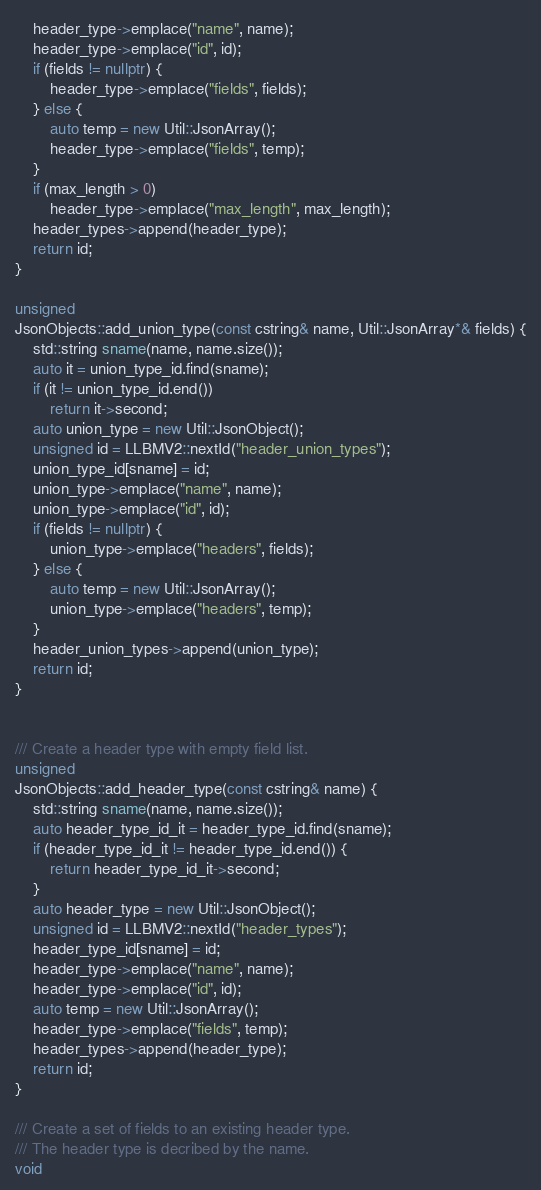Convert code to text. <code><loc_0><loc_0><loc_500><loc_500><_C++_>    header_type->emplace("name", name);
    header_type->emplace("id", id);
    if (fields != nullptr) {
        header_type->emplace("fields", fields);
    } else {
        auto temp = new Util::JsonArray();
        header_type->emplace("fields", temp);
    }
    if (max_length > 0)
        header_type->emplace("max_length", max_length);
    header_types->append(header_type);
    return id;
}

unsigned
JsonObjects::add_union_type(const cstring& name, Util::JsonArray*& fields) {
    std::string sname(name, name.size());
    auto it = union_type_id.find(sname);
    if (it != union_type_id.end())
        return it->second;
    auto union_type = new Util::JsonObject();
    unsigned id = LLBMV2::nextId("header_union_types");
    union_type_id[sname] = id;
    union_type->emplace("name", name);
    union_type->emplace("id", id);
    if (fields != nullptr) {
        union_type->emplace("headers", fields);
    } else {
        auto temp = new Util::JsonArray();
        union_type->emplace("headers", temp);
    }
    header_union_types->append(union_type);
    return id;
}


/// Create a header type with empty field list.
unsigned
JsonObjects::add_header_type(const cstring& name) {
    std::string sname(name, name.size());
    auto header_type_id_it = header_type_id.find(sname);
    if (header_type_id_it != header_type_id.end()) {
        return header_type_id_it->second;
    }
    auto header_type = new Util::JsonObject();
    unsigned id = LLBMV2::nextId("header_types");
    header_type_id[sname] = id;
    header_type->emplace("name", name);
    header_type->emplace("id", id);
    auto temp = new Util::JsonArray();
    header_type->emplace("fields", temp);
    header_types->append(header_type);
    return id;
}

/// Create a set of fields to an existing header type.
/// The header type is decribed by the name.
void</code> 